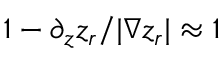<formula> <loc_0><loc_0><loc_500><loc_500>1 - \partial _ { z } z _ { r } / | \nabla z _ { r } | \approx 1</formula> 